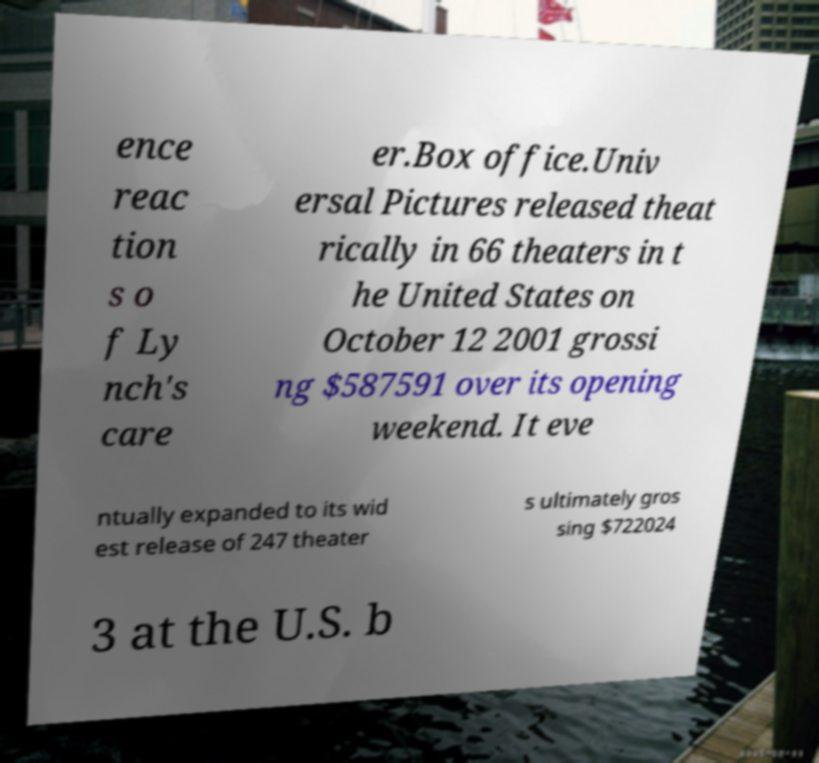What messages or text are displayed in this image? I need them in a readable, typed format. ence reac tion s o f Ly nch's care er.Box office.Univ ersal Pictures released theat rically in 66 theaters in t he United States on October 12 2001 grossi ng $587591 over its opening weekend. It eve ntually expanded to its wid est release of 247 theater s ultimately gros sing $722024 3 at the U.S. b 